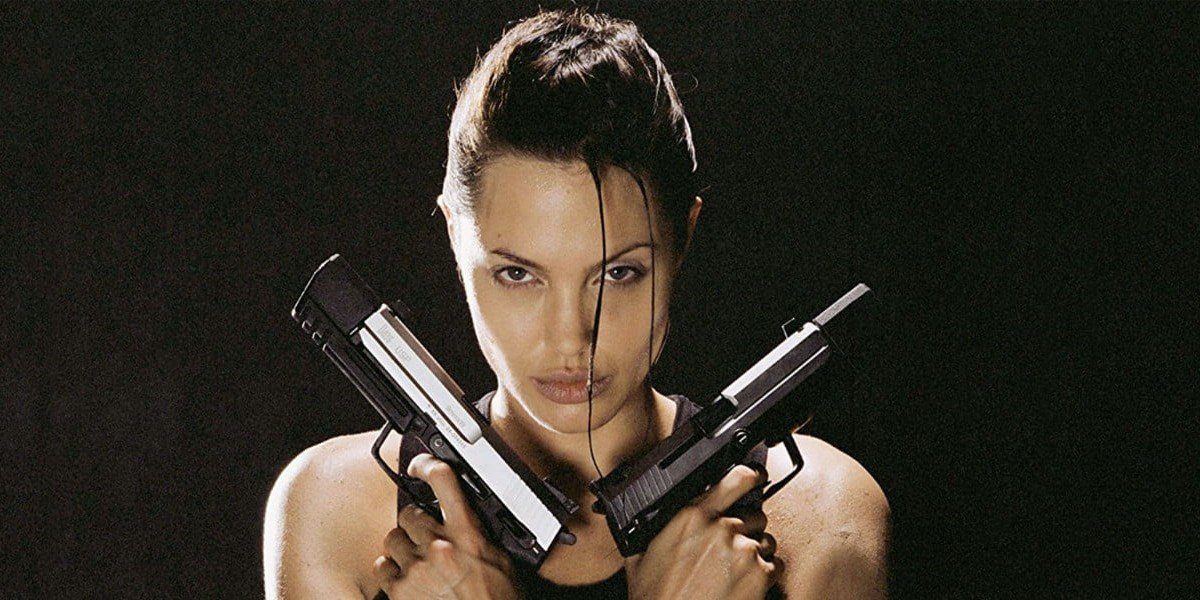What is this photo about'? In this image, the actress is portraying Lara Croft, an iconic character from the movie Tomb Raider. She is depicted in a powerful stance, holding two guns crossed in front of her chest, emphasizing her fearless and adventurous spirit. Her outfit includes a black tank top, matching the dark background, and her hair is styled in a messy bun, adding to her strong and dynamic appearance. The photo angle, taken from below, further accentuates her dominance and strength, symbolizing her capability as a formidable adventurer. 